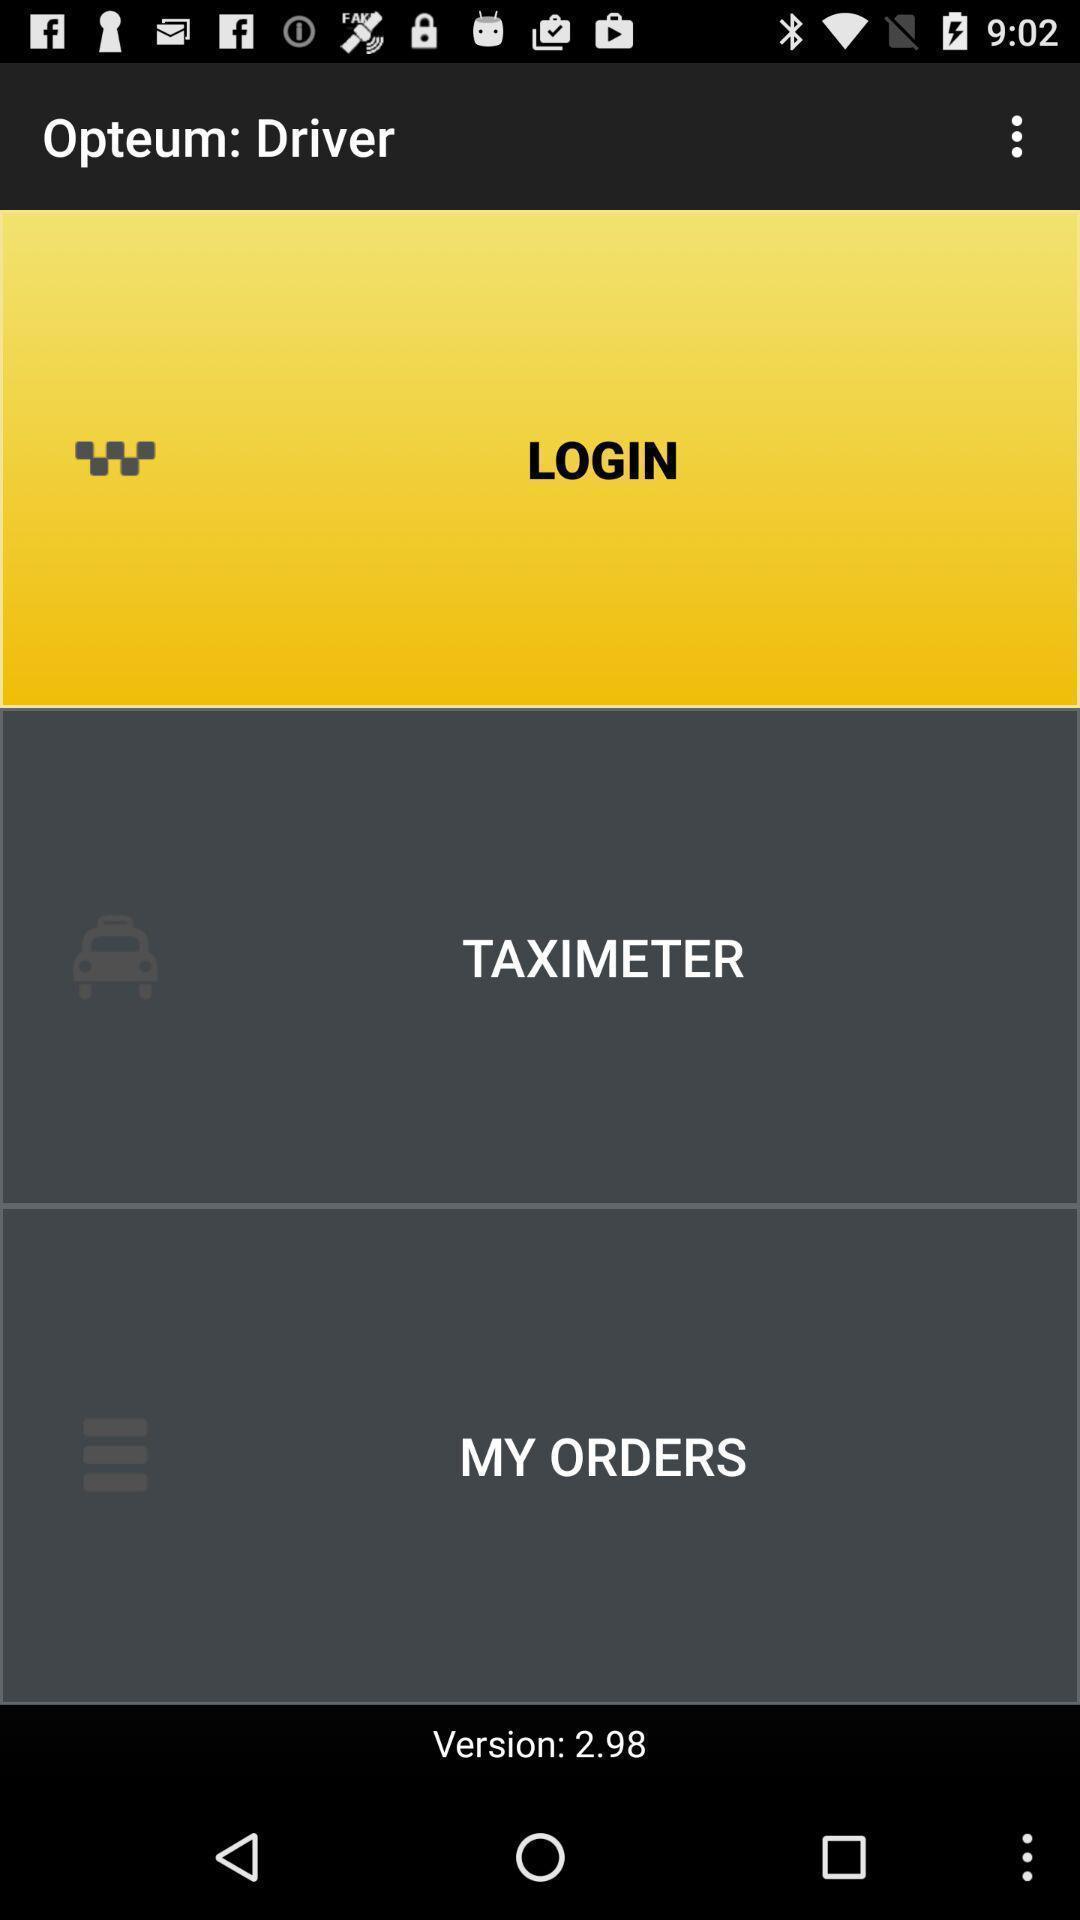Provide a description of this screenshot. Welcome page. 